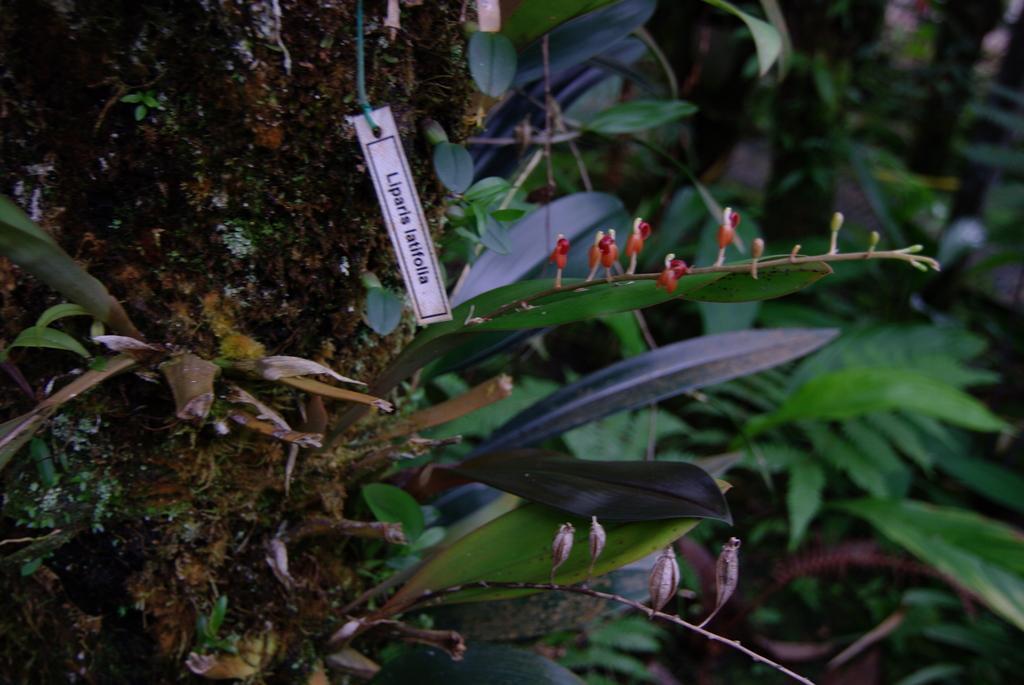In one or two sentences, can you explain what this image depicts? In this image we can see plants. To this plant there are buds. Here we can see a tag. 